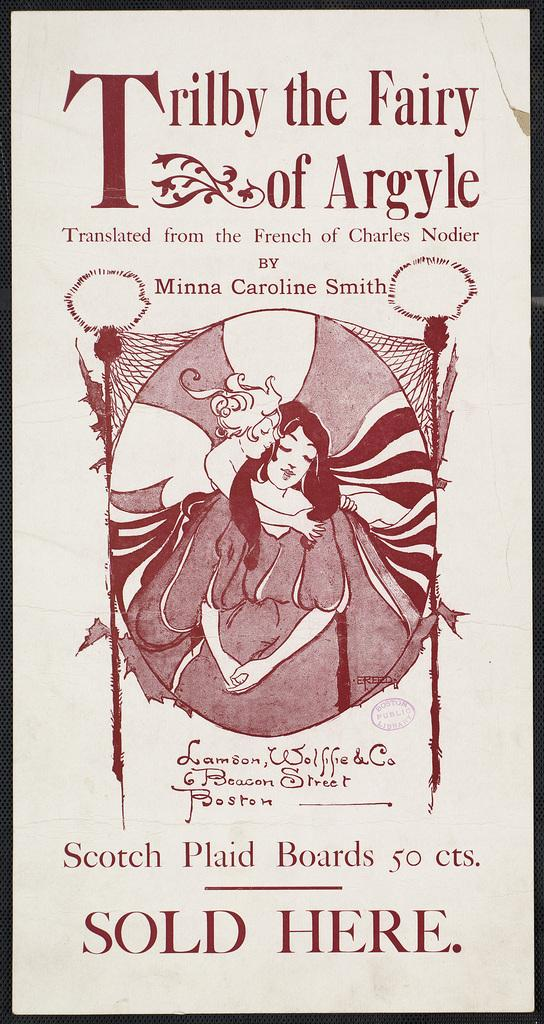<image>
Describe the image concisely. An advertisement poster for Scotch plaid boards which references a book. 